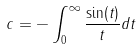<formula> <loc_0><loc_0><loc_500><loc_500>c = - \int _ { 0 } ^ { \infty } \frac { \sin ( t ) } { t } d t</formula> 